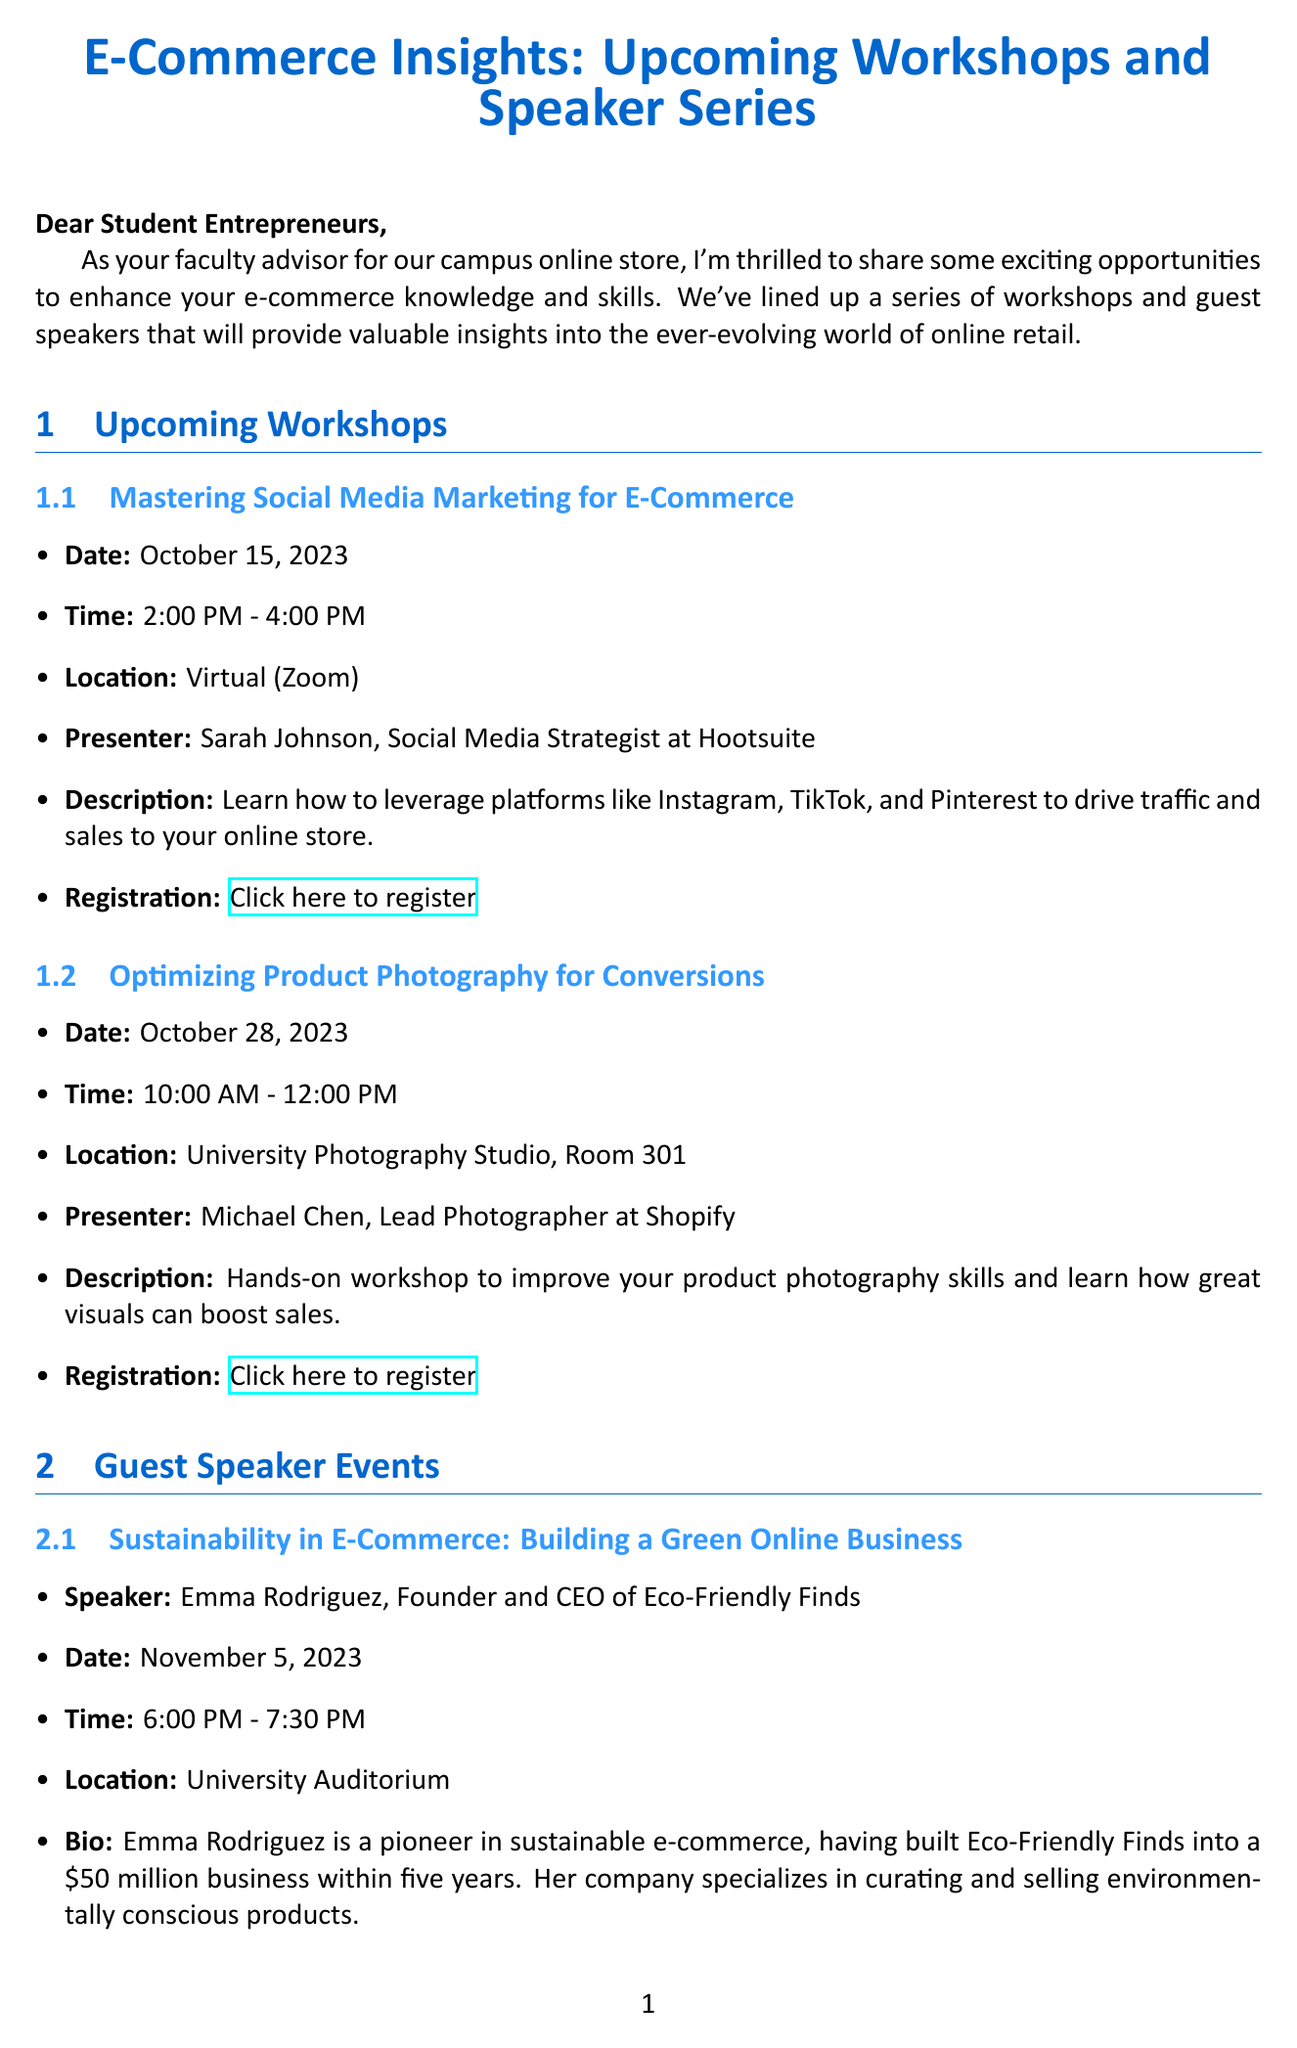What is the title of the newsletter? The title of the newsletter is provided at the beginning of the document, which states "E-Commerce Insights: Upcoming Workshops and Speaker Series."
Answer: E-Commerce Insights: Upcoming Workshops and Speaker Series What is the date of the first workshop? The first workshop listed is "Mastering Social Media Marketing for E-Commerce," which is scheduled for October 15, 2023.
Answer: October 15, 2023 Who is the presenter for the product photography workshop? The document mentions that Michael Chen is the presenter for the workshop on "Optimizing Product Photography for Conversions."
Answer: Michael Chen What time does the guest speaker event with Emma Rodriguez start? According to the document, the event with Emma Rodriguez starts at 6:00 PM on November 5, 2023.
Answer: 6:00 PM Which company does David Patel work for? The document identifies David Patel as the Head of E-Commerce at Nike, indicating his affiliation with the company.
Answer: Nike What are two topics that Emma Rodriguez will discuss in her speech? The topics include "Sourcing sustainable products" and "Marketing to eco-conscious consumers," as mentioned in the bio of the event with Emma Rodriguez.
Answer: Sourcing sustainable products; Marketing to eco-conscious consumers What is the registration link for the social media marketing workshop? The link for registration is provided in the description of the social media marketing workshop, which leads to the specified workshop page.
Answer: https://universityevents.edu/ecommerce-social-media-workshop How long is the workshop on product photography? The duration of the "Optimizing Product Photography for Conversions" workshop is described as 2 hours.
Answer: 2 hours 